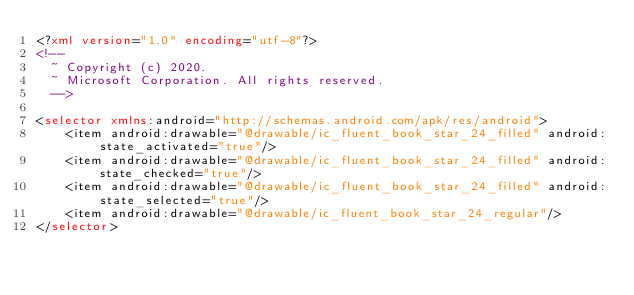<code> <loc_0><loc_0><loc_500><loc_500><_XML_><?xml version="1.0" encoding="utf-8"?>
<!--
  ~ Copyright (c) 2020.
  ~ Microsoft Corporation. All rights reserved.
  -->

<selector xmlns:android="http://schemas.android.com/apk/res/android">
    <item android:drawable="@drawable/ic_fluent_book_star_24_filled" android:state_activated="true"/>
    <item android:drawable="@drawable/ic_fluent_book_star_24_filled" android:state_checked="true"/>
    <item android:drawable="@drawable/ic_fluent_book_star_24_filled" android:state_selected="true"/>
    <item android:drawable="@drawable/ic_fluent_book_star_24_regular"/>
</selector>
</code> 